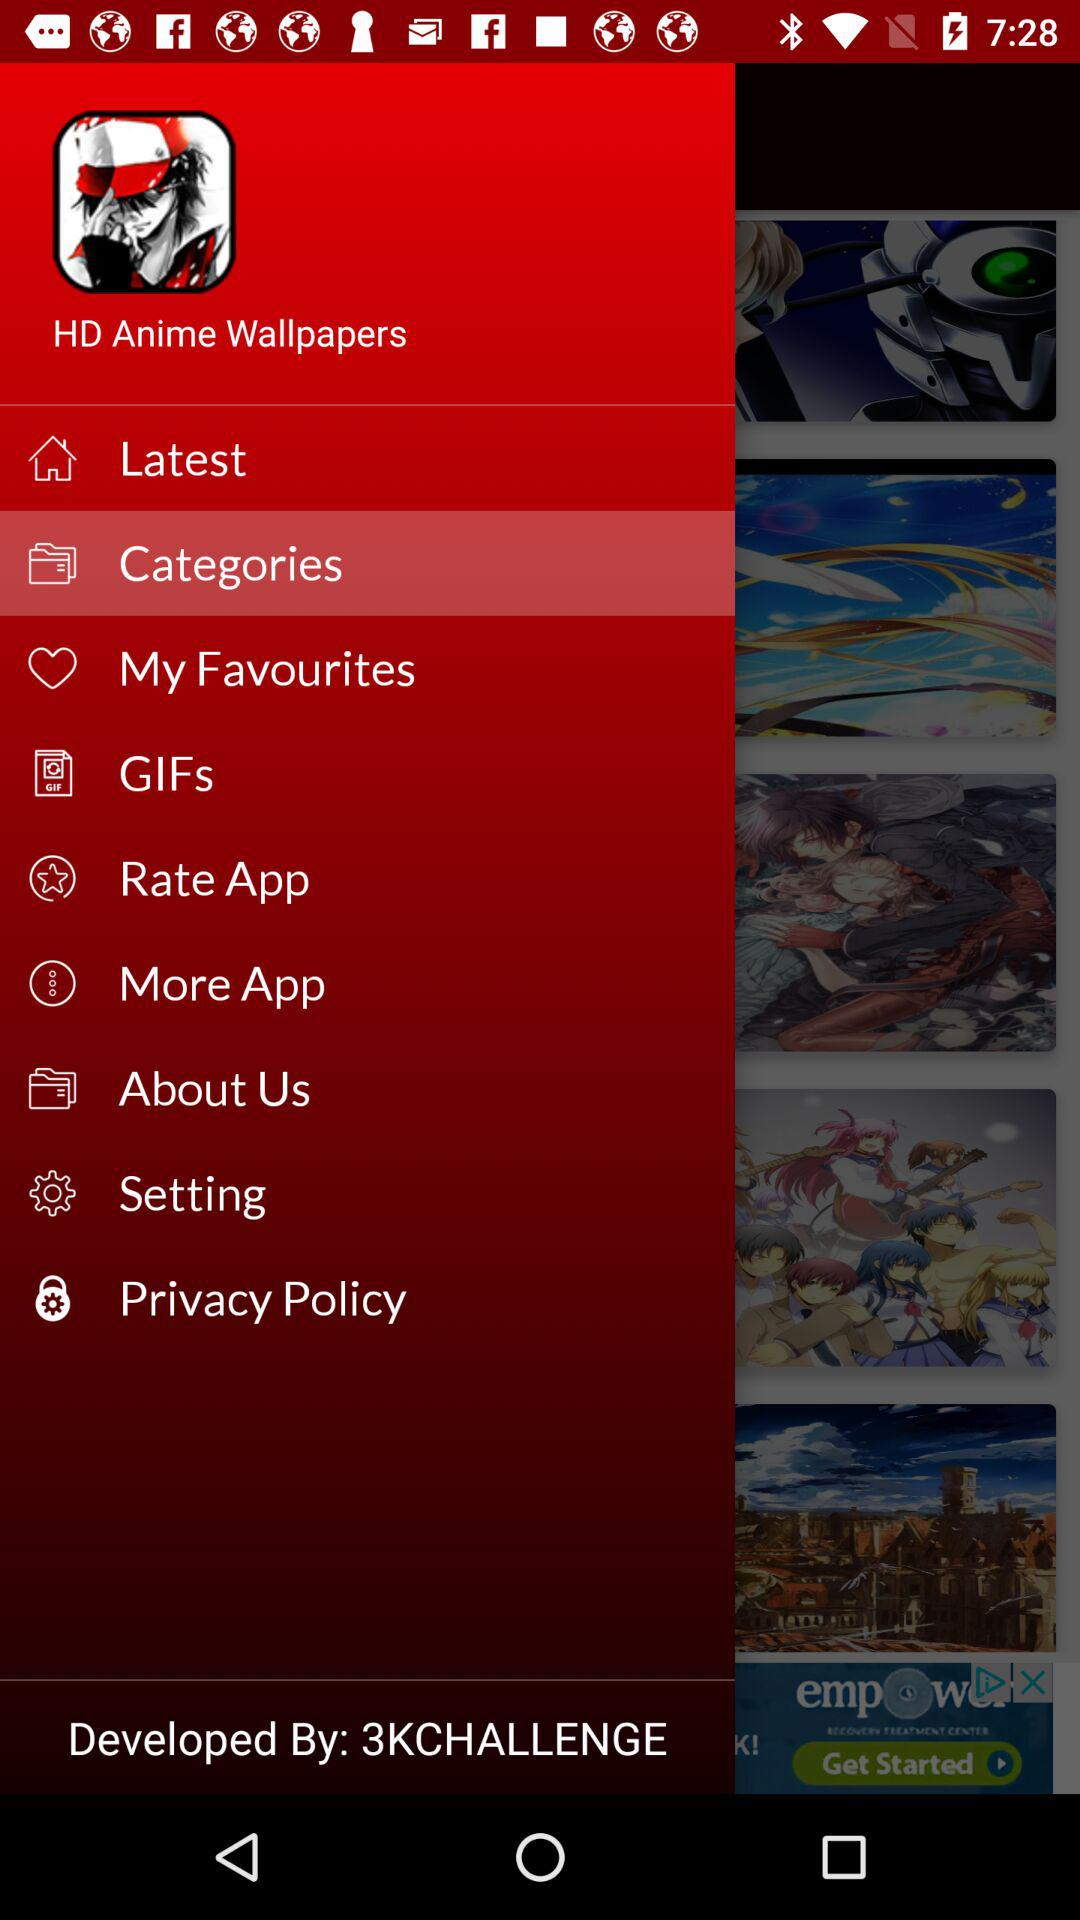What is the name of the application? The name of the application is "HD Anime Wallpapers". 